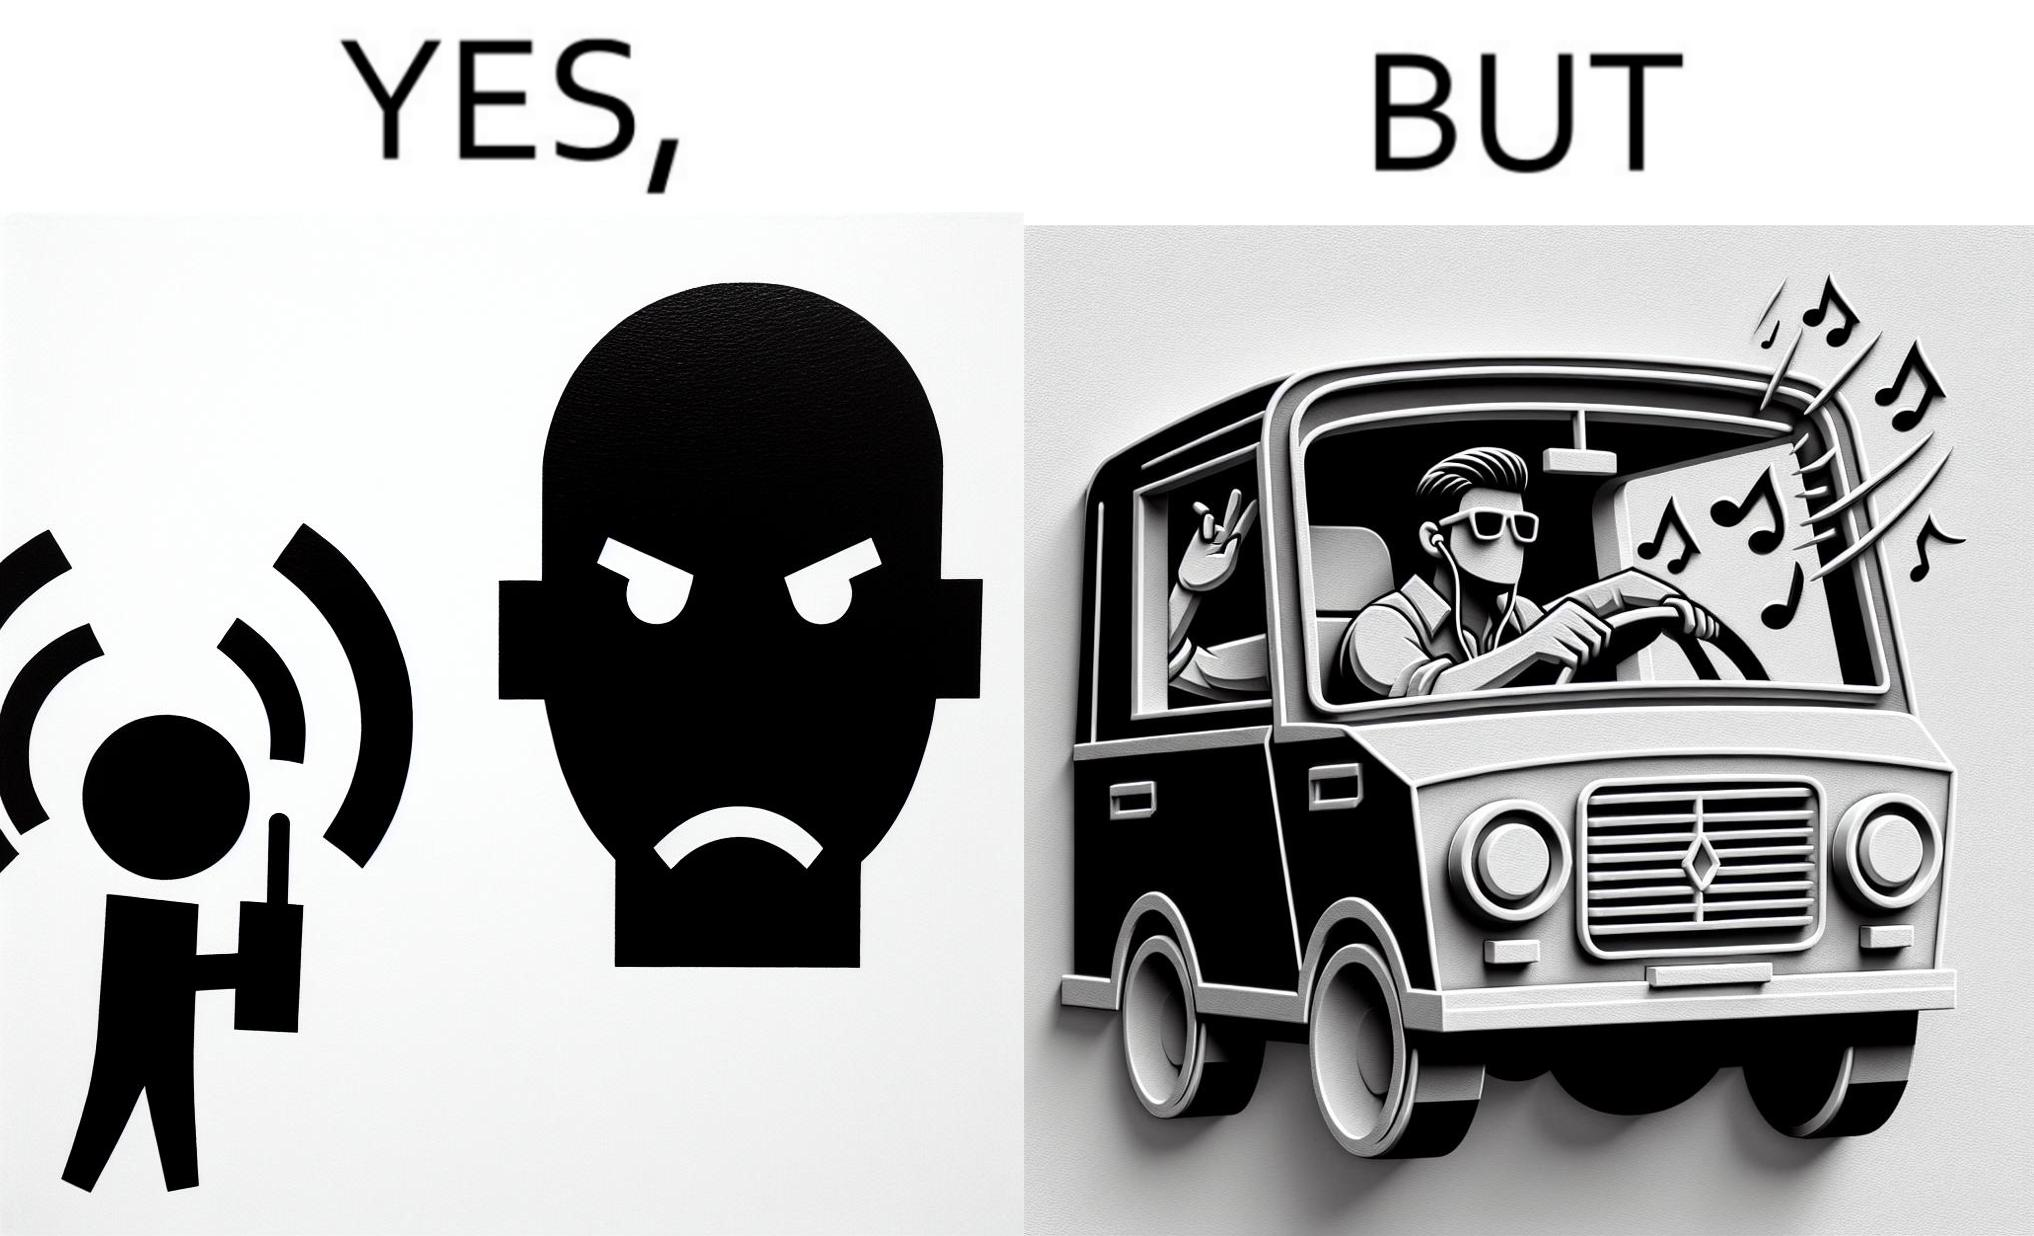What does this image depict? The image is funny because while the man does not like the boy playing music loudly on his phone, the man himself is okay with doing the same thing with his car and playing loud music in the car with the sound coming out of the car. 